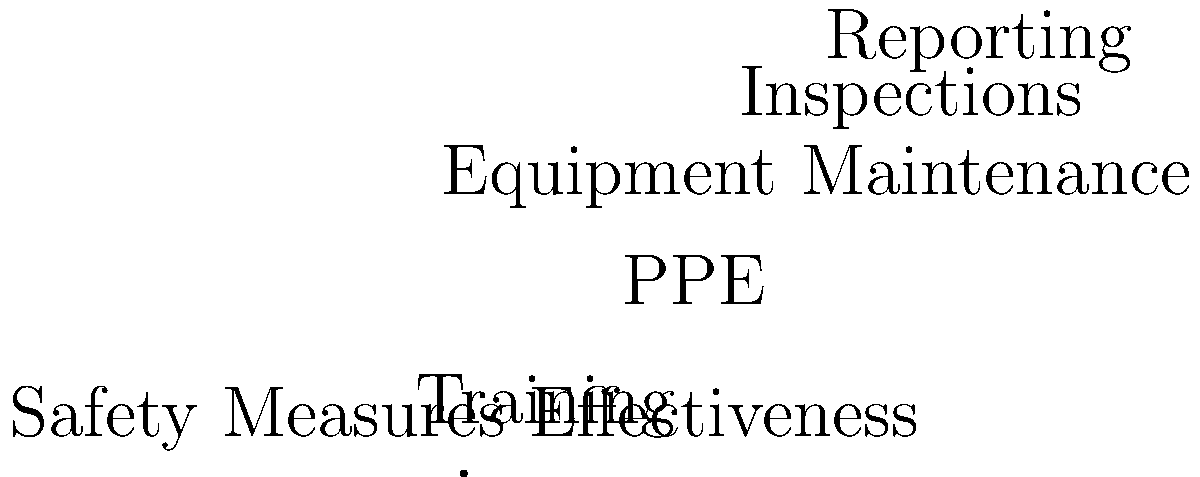The pie chart above represents the effectiveness of various safety measures implemented in your organization. Which two measures combined account for more than 50% of the total effectiveness? To solve this problem, we need to follow these steps:

1. Identify the percentages for each safety measure:
   - Training: 30%
   - PPE (Personal Protective Equipment): 25%
   - Equipment Maintenance: 20%
   - Inspections: 15%
   - Reporting: 10%

2. Calculate the sum of percentages for each pair of measures:
   - Training + PPE: 30% + 25% = 55%
   - Training + Equipment Maintenance: 30% + 20% = 50%
   - Training + Inspections: 30% + 15% = 45%
   - Training + Reporting: 30% + 10% = 40%
   - PPE + Equipment Maintenance: 25% + 20% = 45%
   - PPE + Inspections: 25% + 15% = 40%
   - PPE + Reporting: 25% + 10% = 35%
   - Equipment Maintenance + Inspections: 20% + 15% = 35%
   - Equipment Maintenance + Reporting: 20% + 10% = 30%
   - Inspections + Reporting: 15% + 10% = 25%

3. Identify the pair that exceeds 50%:
   Training (30%) + PPE (25%) = 55%, which is greater than 50%

Therefore, Training and PPE combined account for more than 50% of the total effectiveness of safety measures.
Answer: Training and PPE 